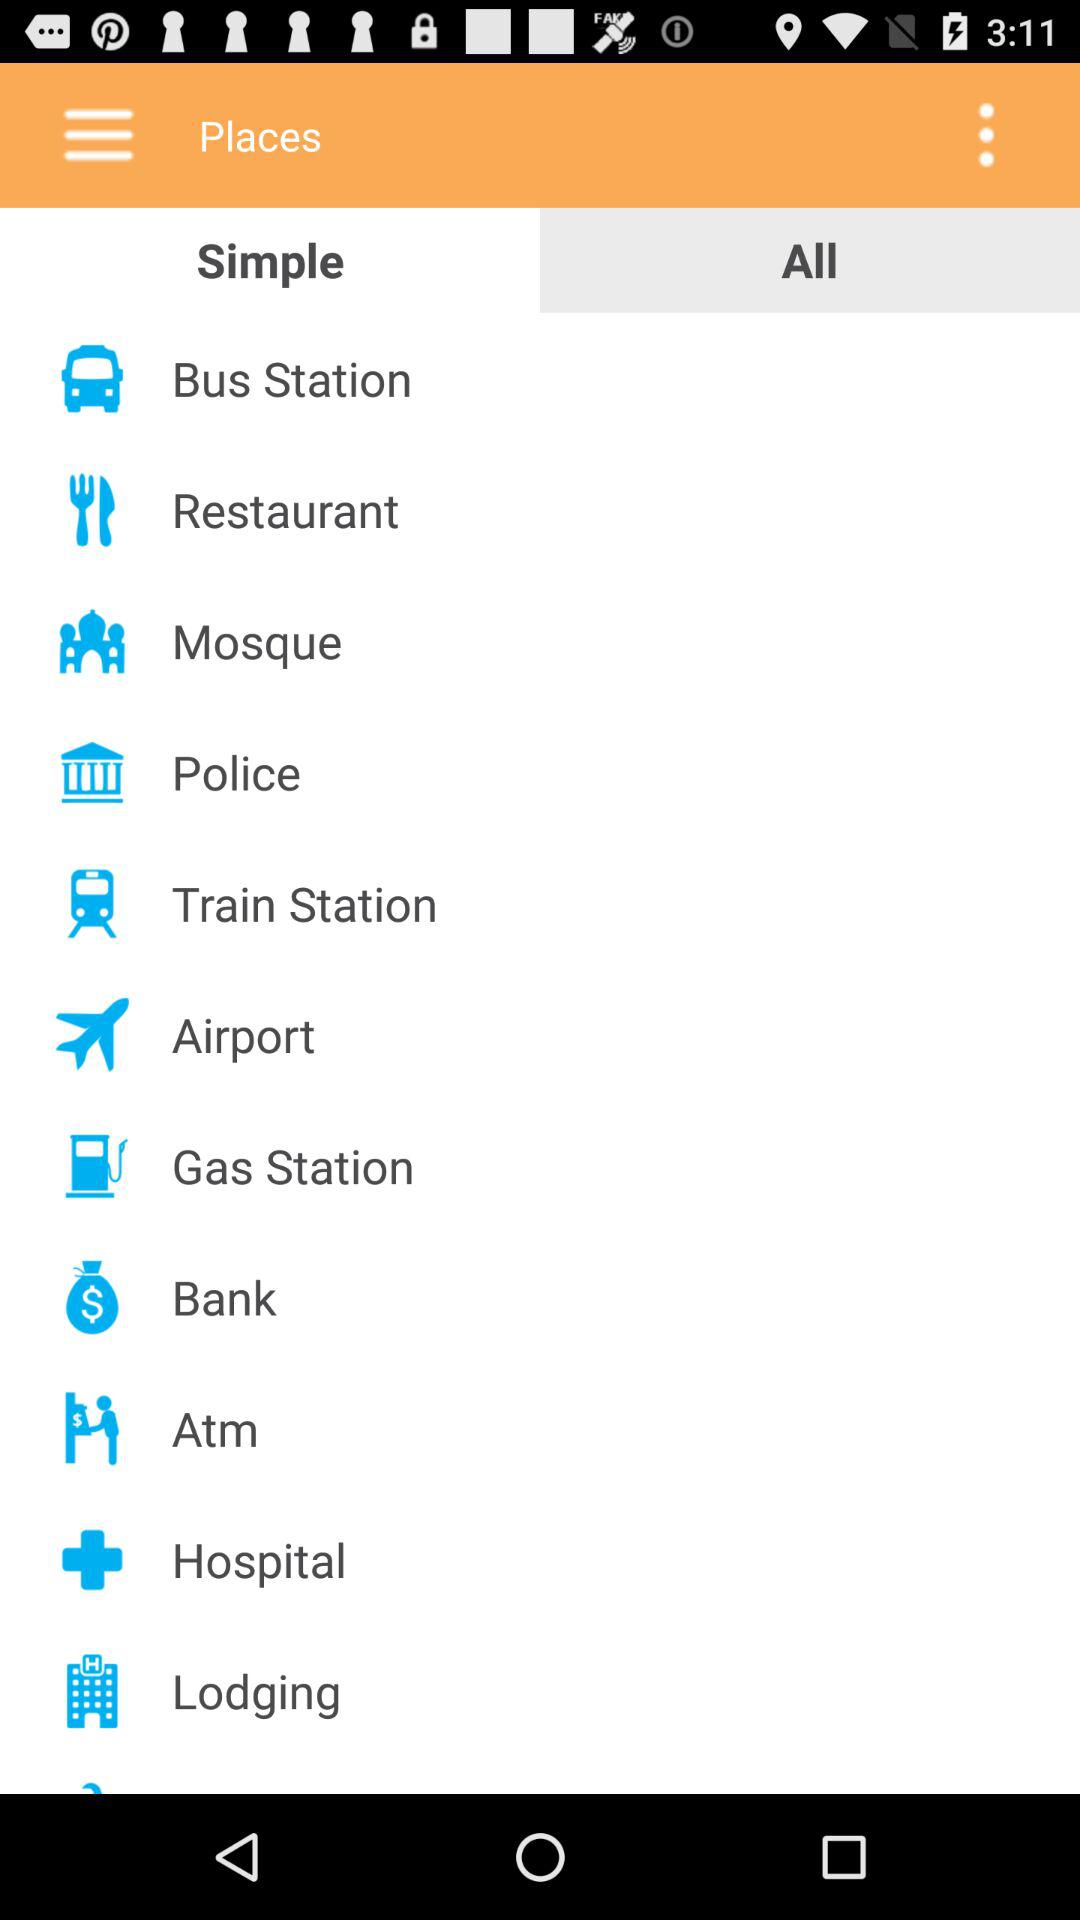Which tab has been selected? The selected tab is "All". 